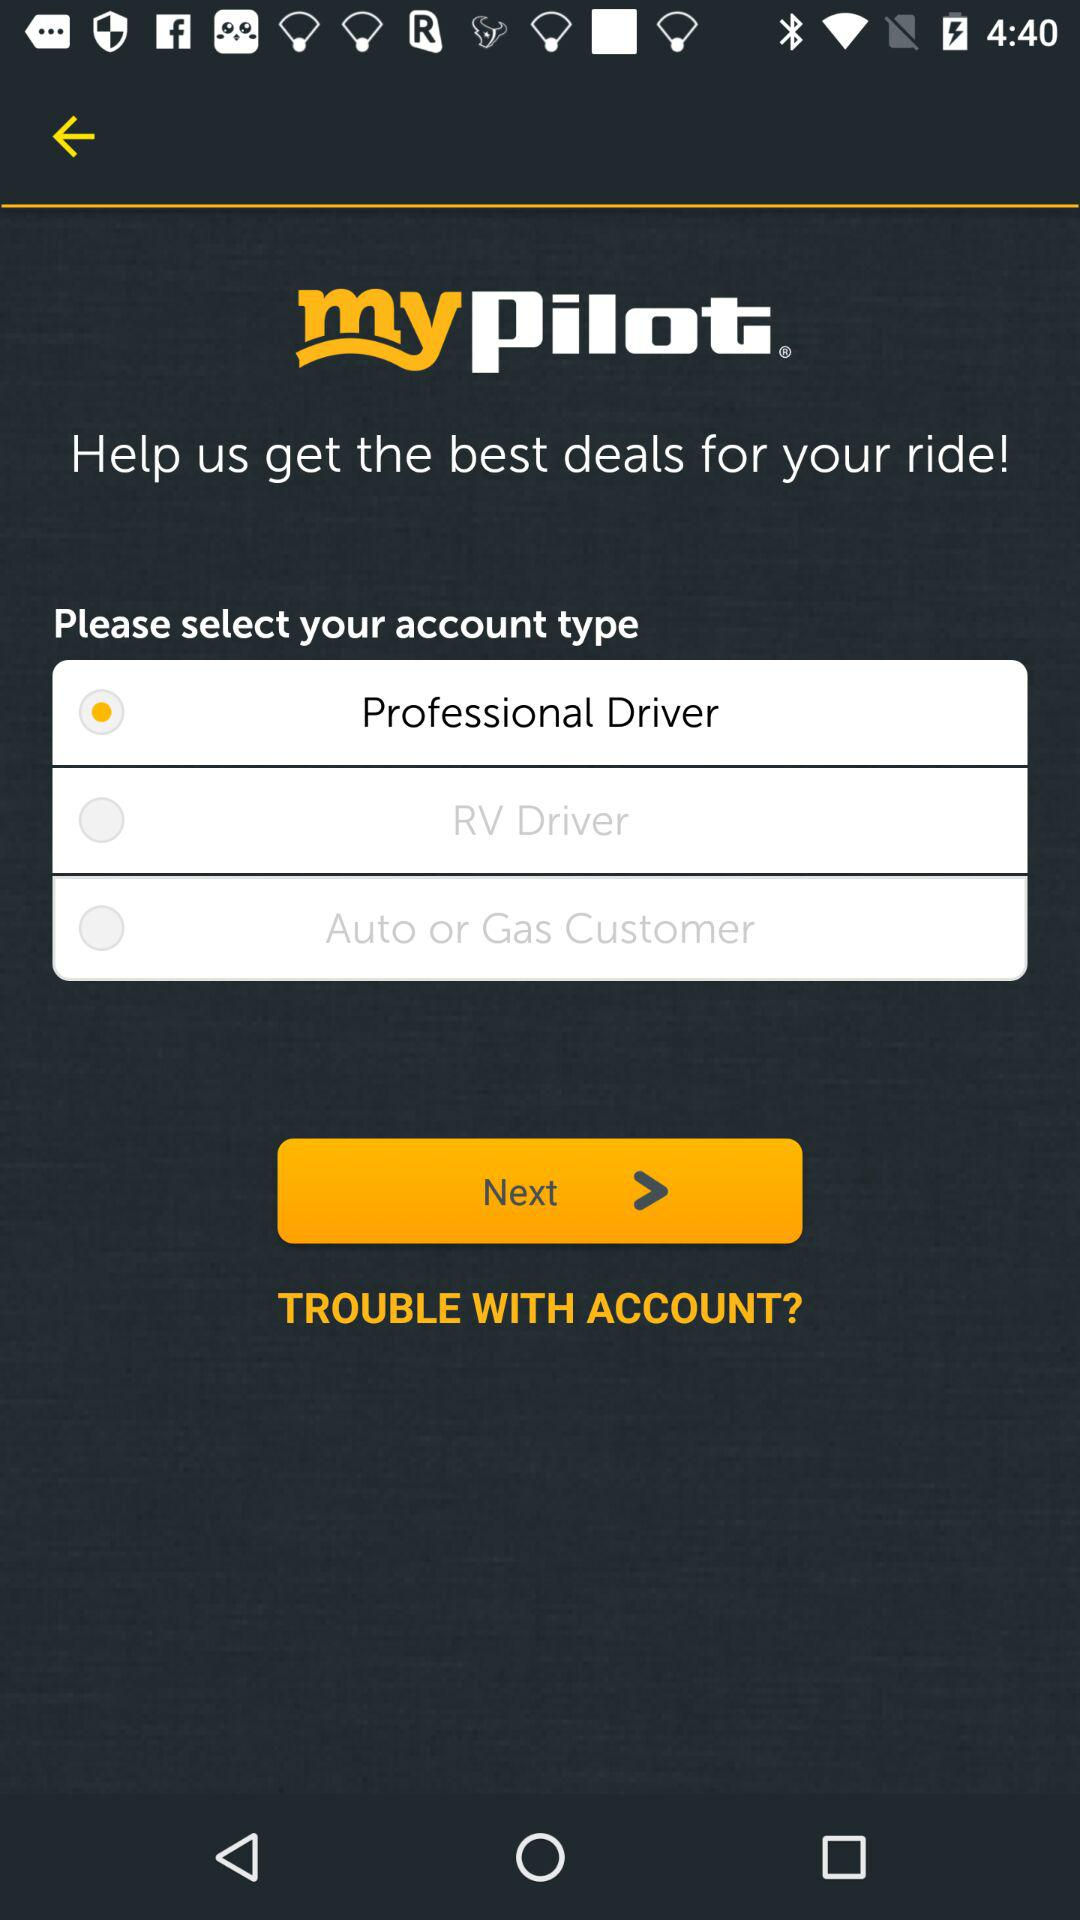Where do we go if we have trouble with our account?
When the provided information is insufficient, respond with <no answer>. <no answer> 